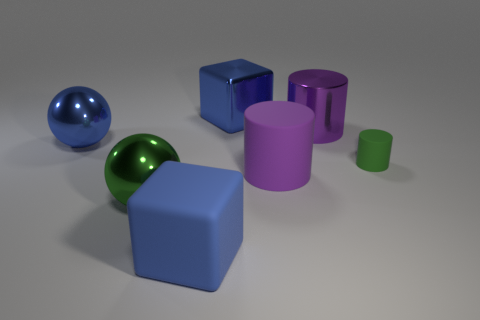Is there any other thing that is the same material as the large green sphere?
Keep it short and to the point. Yes. How many things are big blue shiny objects on the right side of the big blue matte object or big balls behind the small matte object?
Offer a very short reply. 2. Is the big green sphere made of the same material as the blue object that is on the left side of the green sphere?
Provide a succinct answer. Yes. The large blue object that is behind the purple matte object and in front of the metal block has what shape?
Provide a succinct answer. Sphere. How many other objects are the same color as the small matte cylinder?
Offer a very short reply. 1. The tiny matte thing is what shape?
Your answer should be compact. Cylinder. The shiny cube that is on the left side of the small thing to the right of the purple matte object is what color?
Provide a succinct answer. Blue. There is a metallic cylinder; does it have the same color as the thing that is in front of the green metal object?
Your answer should be compact. No. The large object that is left of the large blue matte object and behind the green metal thing is made of what material?
Ensure brevity in your answer.  Metal. Are there any matte blocks that have the same size as the green matte thing?
Your response must be concise. No. 